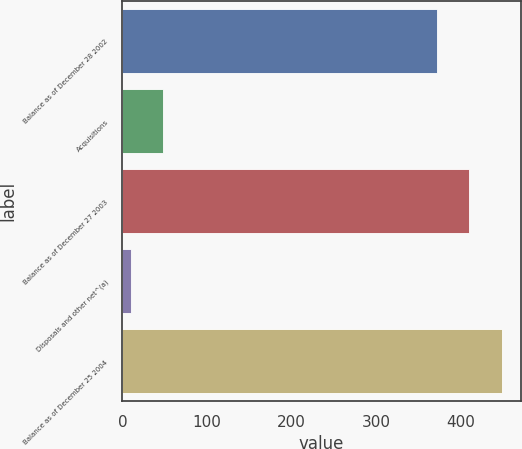Convert chart to OTSL. <chart><loc_0><loc_0><loc_500><loc_500><bar_chart><fcel>Balance as of December 28 2002<fcel>Acquisitions<fcel>Balance as of December 27 2003<fcel>Disposals and other net^(a)<fcel>Balance as of December 25 2004<nl><fcel>372<fcel>48.5<fcel>410.5<fcel>10<fcel>449<nl></chart> 